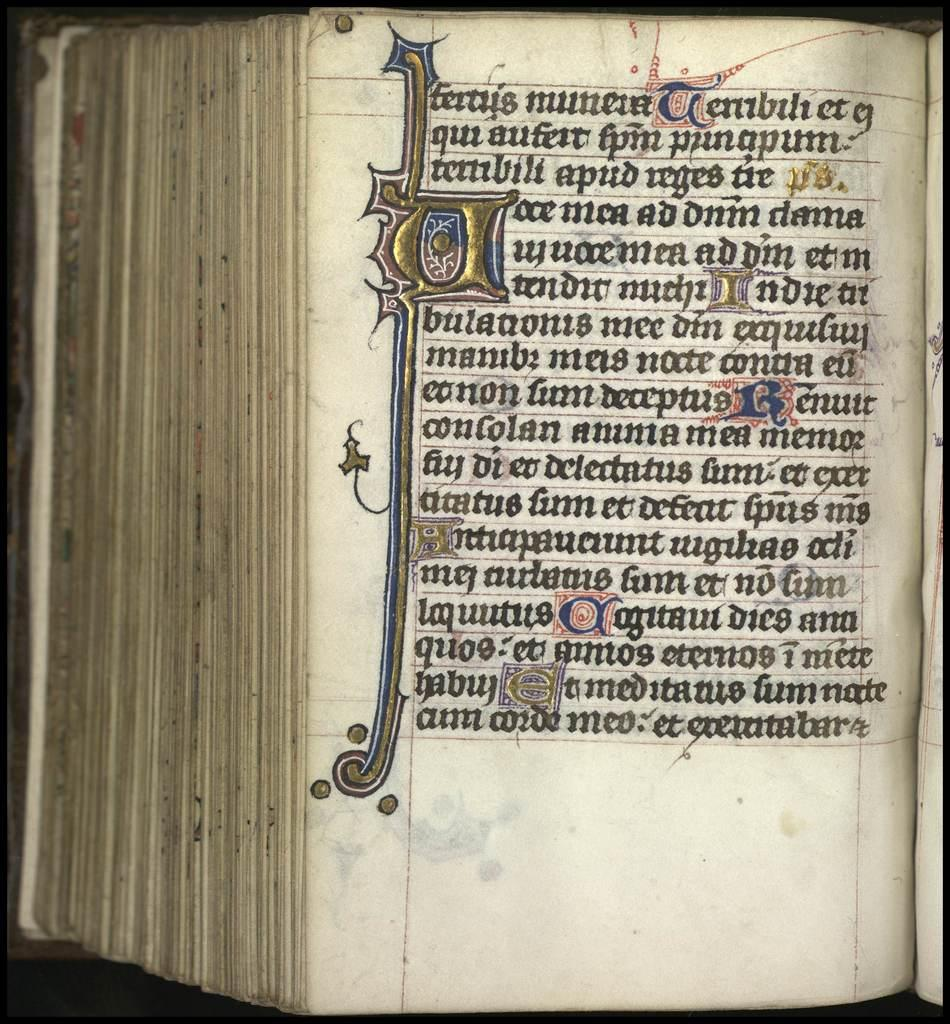<image>
Summarize the visual content of the image. an older book opened to a page in another language with the letters et on the last line. 